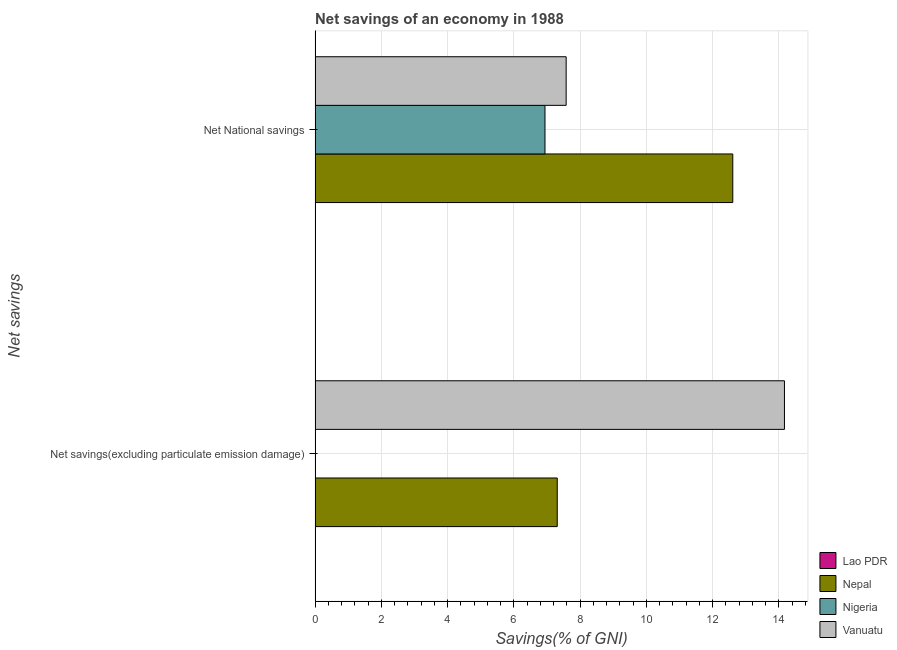How many bars are there on the 1st tick from the top?
Give a very brief answer. 3. How many bars are there on the 2nd tick from the bottom?
Keep it short and to the point. 3. What is the label of the 1st group of bars from the top?
Your response must be concise. Net National savings. What is the net national savings in Nigeria?
Offer a terse response. 6.94. Across all countries, what is the maximum net savings(excluding particulate emission damage)?
Ensure brevity in your answer.  14.16. Across all countries, what is the minimum net national savings?
Make the answer very short. 0. In which country was the net national savings maximum?
Your response must be concise. Nepal. What is the total net savings(excluding particulate emission damage) in the graph?
Offer a terse response. 21.47. What is the difference between the net national savings in Nepal and that in Nigeria?
Keep it short and to the point. 5.67. What is the difference between the net national savings in Nigeria and the net savings(excluding particulate emission damage) in Vanuatu?
Your answer should be compact. -7.23. What is the average net national savings per country?
Make the answer very short. 6.78. What is the difference between the net savings(excluding particulate emission damage) and net national savings in Vanuatu?
Give a very brief answer. 6.59. In how many countries, is the net national savings greater than 11.6 %?
Keep it short and to the point. 1. What is the ratio of the net national savings in Vanuatu to that in Nigeria?
Offer a very short reply. 1.09. Are all the bars in the graph horizontal?
Your answer should be compact. Yes. How many countries are there in the graph?
Your answer should be compact. 4. What is the difference between two consecutive major ticks on the X-axis?
Give a very brief answer. 2. Where does the legend appear in the graph?
Ensure brevity in your answer.  Bottom right. How many legend labels are there?
Provide a succinct answer. 4. What is the title of the graph?
Your response must be concise. Net savings of an economy in 1988. What is the label or title of the X-axis?
Provide a short and direct response. Savings(% of GNI). What is the label or title of the Y-axis?
Keep it short and to the point. Net savings. What is the Savings(% of GNI) in Nepal in Net savings(excluding particulate emission damage)?
Your response must be concise. 7.31. What is the Savings(% of GNI) in Nigeria in Net savings(excluding particulate emission damage)?
Your answer should be very brief. 0. What is the Savings(% of GNI) of Vanuatu in Net savings(excluding particulate emission damage)?
Your response must be concise. 14.16. What is the Savings(% of GNI) in Lao PDR in Net National savings?
Your answer should be compact. 0. What is the Savings(% of GNI) in Nepal in Net National savings?
Ensure brevity in your answer.  12.61. What is the Savings(% of GNI) of Nigeria in Net National savings?
Provide a succinct answer. 6.94. What is the Savings(% of GNI) of Vanuatu in Net National savings?
Your answer should be compact. 7.58. Across all Net savings, what is the maximum Savings(% of GNI) in Nepal?
Provide a succinct answer. 12.61. Across all Net savings, what is the maximum Savings(% of GNI) in Nigeria?
Give a very brief answer. 6.94. Across all Net savings, what is the maximum Savings(% of GNI) in Vanuatu?
Offer a very short reply. 14.16. Across all Net savings, what is the minimum Savings(% of GNI) in Nepal?
Offer a terse response. 7.31. Across all Net savings, what is the minimum Savings(% of GNI) of Vanuatu?
Provide a short and direct response. 7.58. What is the total Savings(% of GNI) in Lao PDR in the graph?
Your answer should be compact. 0. What is the total Savings(% of GNI) in Nepal in the graph?
Your answer should be compact. 19.91. What is the total Savings(% of GNI) of Nigeria in the graph?
Provide a succinct answer. 6.94. What is the total Savings(% of GNI) of Vanuatu in the graph?
Give a very brief answer. 21.74. What is the difference between the Savings(% of GNI) of Nepal in Net savings(excluding particulate emission damage) and that in Net National savings?
Offer a terse response. -5.3. What is the difference between the Savings(% of GNI) in Vanuatu in Net savings(excluding particulate emission damage) and that in Net National savings?
Ensure brevity in your answer.  6.59. What is the difference between the Savings(% of GNI) in Nepal in Net savings(excluding particulate emission damage) and the Savings(% of GNI) in Nigeria in Net National savings?
Ensure brevity in your answer.  0.37. What is the difference between the Savings(% of GNI) of Nepal in Net savings(excluding particulate emission damage) and the Savings(% of GNI) of Vanuatu in Net National savings?
Your response must be concise. -0.27. What is the average Savings(% of GNI) of Lao PDR per Net savings?
Ensure brevity in your answer.  0. What is the average Savings(% of GNI) of Nepal per Net savings?
Give a very brief answer. 9.96. What is the average Savings(% of GNI) of Nigeria per Net savings?
Offer a terse response. 3.47. What is the average Savings(% of GNI) in Vanuatu per Net savings?
Keep it short and to the point. 10.87. What is the difference between the Savings(% of GNI) in Nepal and Savings(% of GNI) in Vanuatu in Net savings(excluding particulate emission damage)?
Provide a short and direct response. -6.86. What is the difference between the Savings(% of GNI) of Nepal and Savings(% of GNI) of Nigeria in Net National savings?
Offer a very short reply. 5.67. What is the difference between the Savings(% of GNI) in Nepal and Savings(% of GNI) in Vanuatu in Net National savings?
Give a very brief answer. 5.03. What is the difference between the Savings(% of GNI) in Nigeria and Savings(% of GNI) in Vanuatu in Net National savings?
Ensure brevity in your answer.  -0.64. What is the ratio of the Savings(% of GNI) of Nepal in Net savings(excluding particulate emission damage) to that in Net National savings?
Give a very brief answer. 0.58. What is the ratio of the Savings(% of GNI) of Vanuatu in Net savings(excluding particulate emission damage) to that in Net National savings?
Make the answer very short. 1.87. What is the difference between the highest and the second highest Savings(% of GNI) in Nepal?
Provide a short and direct response. 5.3. What is the difference between the highest and the second highest Savings(% of GNI) of Vanuatu?
Offer a terse response. 6.59. What is the difference between the highest and the lowest Savings(% of GNI) of Nepal?
Ensure brevity in your answer.  5.3. What is the difference between the highest and the lowest Savings(% of GNI) in Nigeria?
Your answer should be compact. 6.94. What is the difference between the highest and the lowest Savings(% of GNI) of Vanuatu?
Make the answer very short. 6.59. 